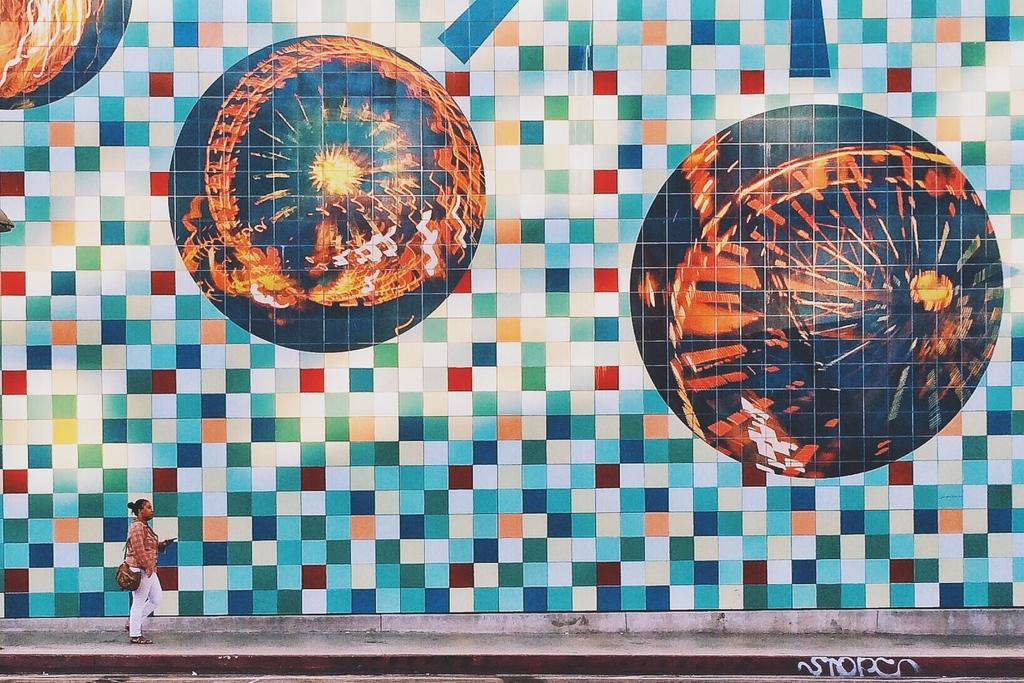Who is present in the image? There is a woman in the image. What is the woman doing in the image? The woman is walking on a pathway. What is the woman carrying in the image? The woman is wearing a bag. What can be seen on the wall beside the woman? There is a painting on a wall beside the woman. What type of hair is visible on the woman's woolen nose in the image? There is no mention of hair or a woolen nose in the image; the woman is simply walking on a pathway and wearing a bag. 